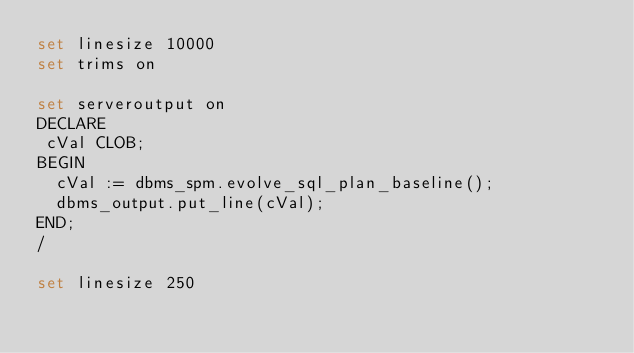<code> <loc_0><loc_0><loc_500><loc_500><_SQL_>set linesize 10000
set trims on

set serveroutput on
DECLARE
 cVal CLOB;
BEGIN
  cVal := dbms_spm.evolve_sql_plan_baseline();
  dbms_output.put_line(cVal);
END;
/

set linesize 250
</code> 